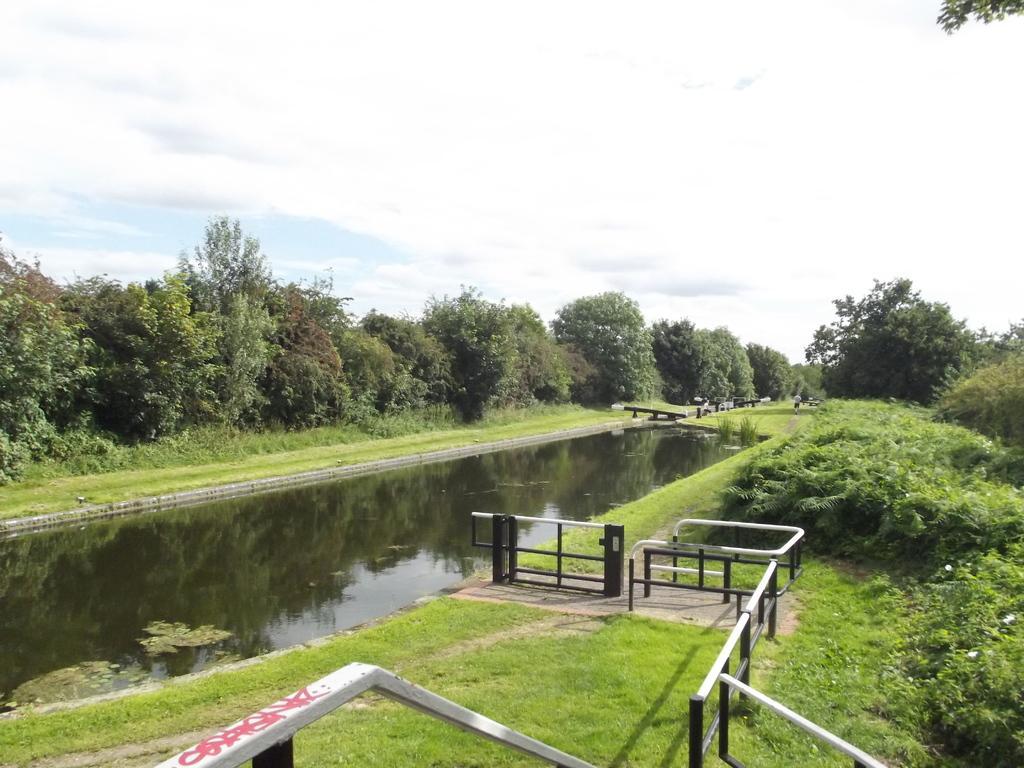How would you summarize this image in a sentence or two? There is fencing near grass on the ground and a lake. On the right side, there are plants and trees on the ground. In the background, there are plants, grass and trees on the ground and there are clouds in the blue sky. 